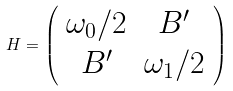<formula> <loc_0><loc_0><loc_500><loc_500>H = \left ( \begin{array} { c c } \omega _ { 0 } / 2 & B ^ { \prime } \\ B ^ { \prime } & \omega _ { 1 } / 2 \end{array} \right )</formula> 